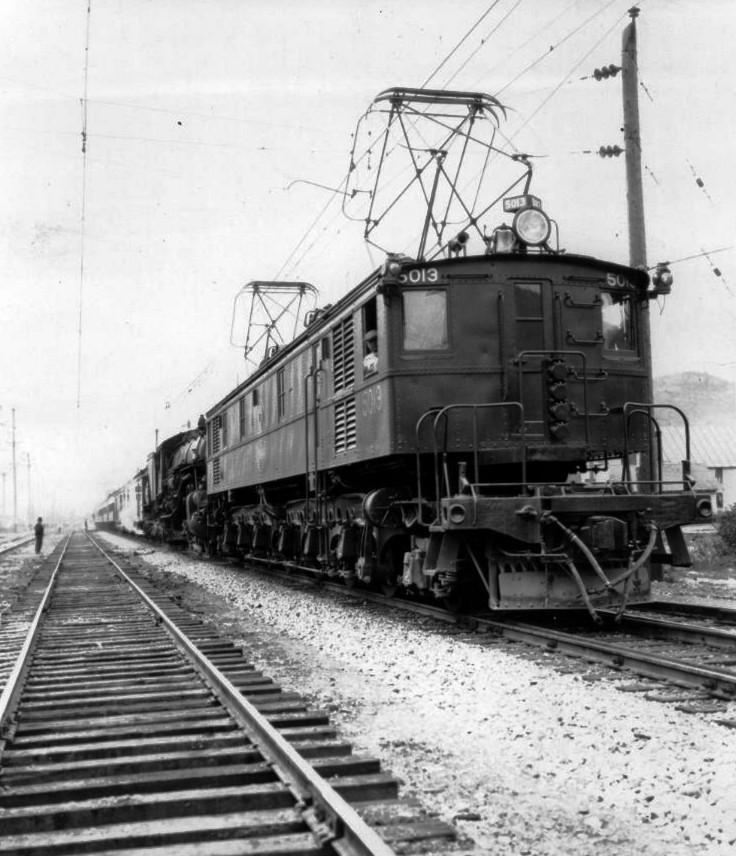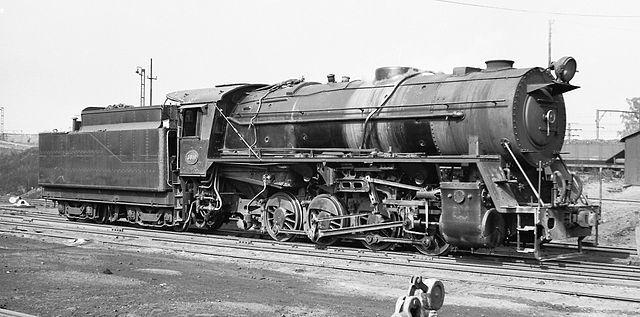The first image is the image on the left, the second image is the image on the right. Examine the images to the left and right. Is the description "In one vintage image, the engineer is visible through the window of a train heading rightward." accurate? Answer yes or no. Yes. The first image is the image on the left, the second image is the image on the right. Considering the images on both sides, is "Each train is run by a cable railway." valid? Answer yes or no. No. 